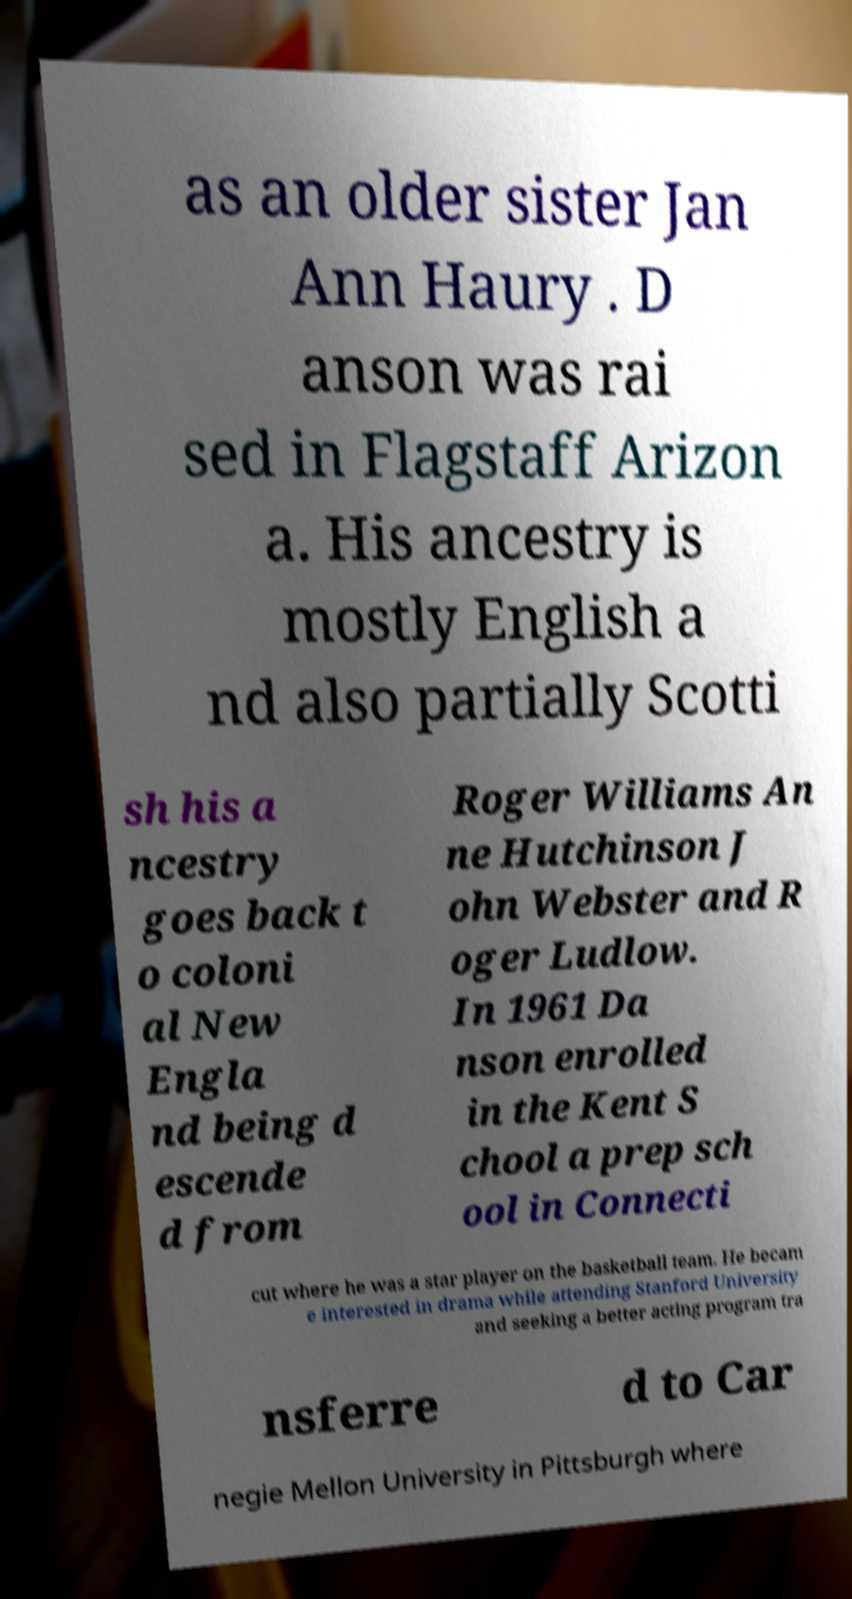Could you assist in decoding the text presented in this image and type it out clearly? as an older sister Jan Ann Haury . D anson was rai sed in Flagstaff Arizon a. His ancestry is mostly English a nd also partially Scotti sh his a ncestry goes back t o coloni al New Engla nd being d escende d from Roger Williams An ne Hutchinson J ohn Webster and R oger Ludlow. In 1961 Da nson enrolled in the Kent S chool a prep sch ool in Connecti cut where he was a star player on the basketball team. He becam e interested in drama while attending Stanford University and seeking a better acting program tra nsferre d to Car negie Mellon University in Pittsburgh where 